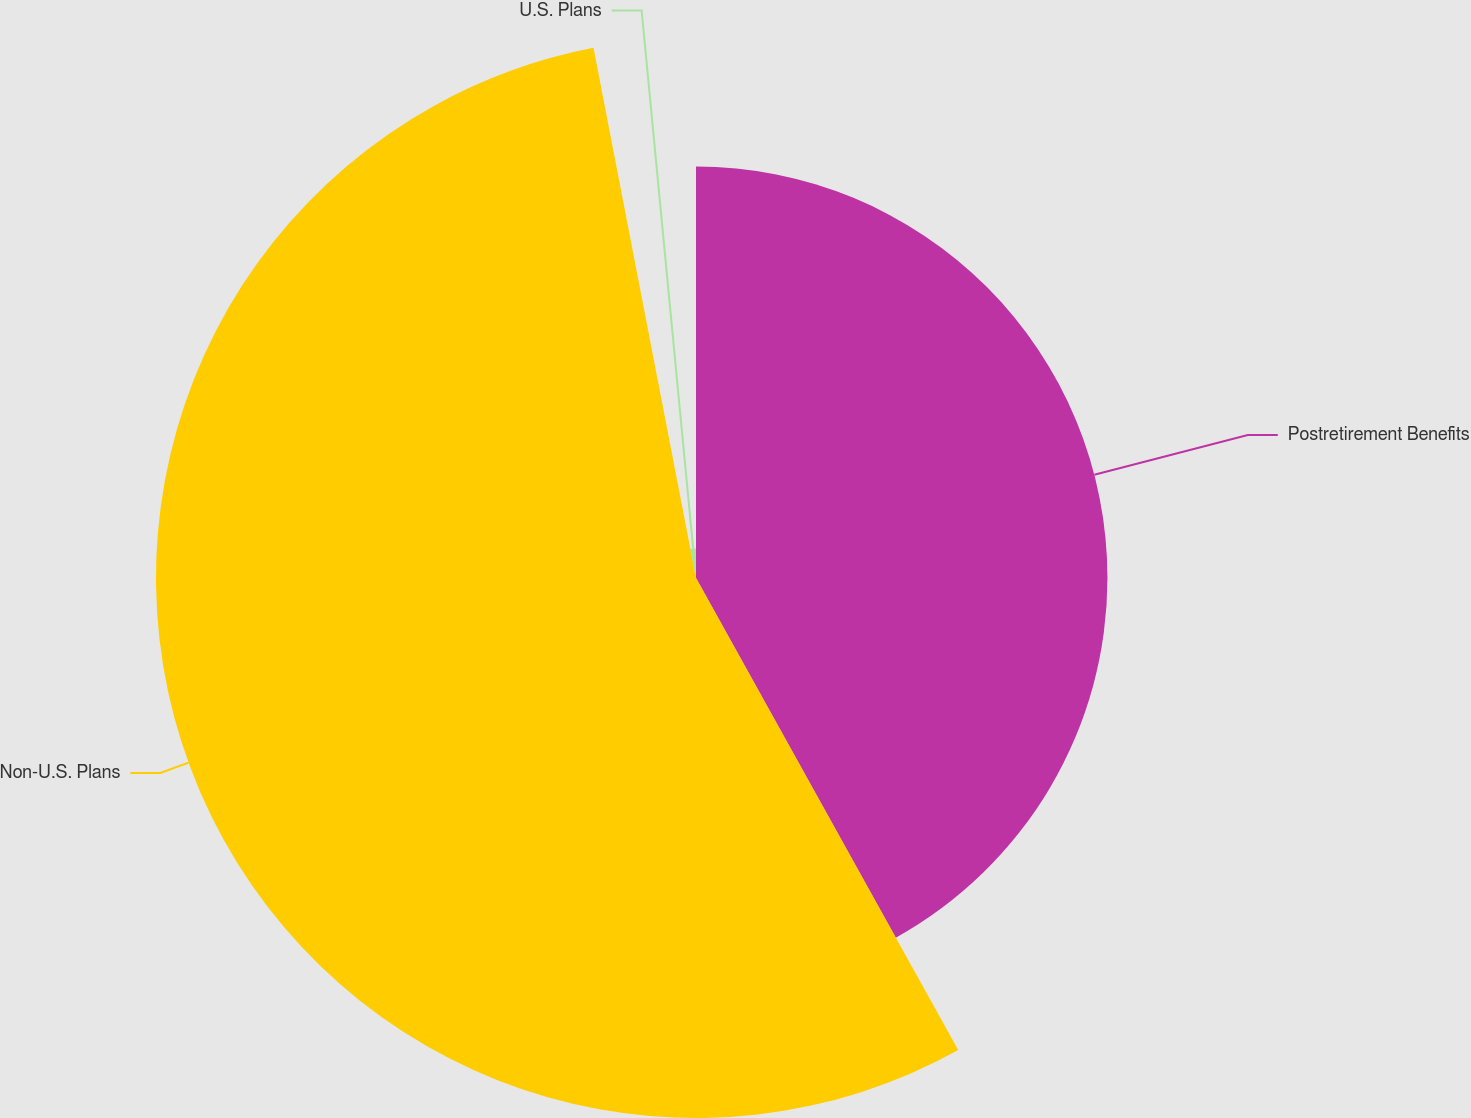Convert chart to OTSL. <chart><loc_0><loc_0><loc_500><loc_500><pie_chart><fcel>Postretirement Benefits<fcel>Non-U.S. Plans<fcel>U.S. Plans<nl><fcel>41.93%<fcel>55.03%<fcel>3.04%<nl></chart> 